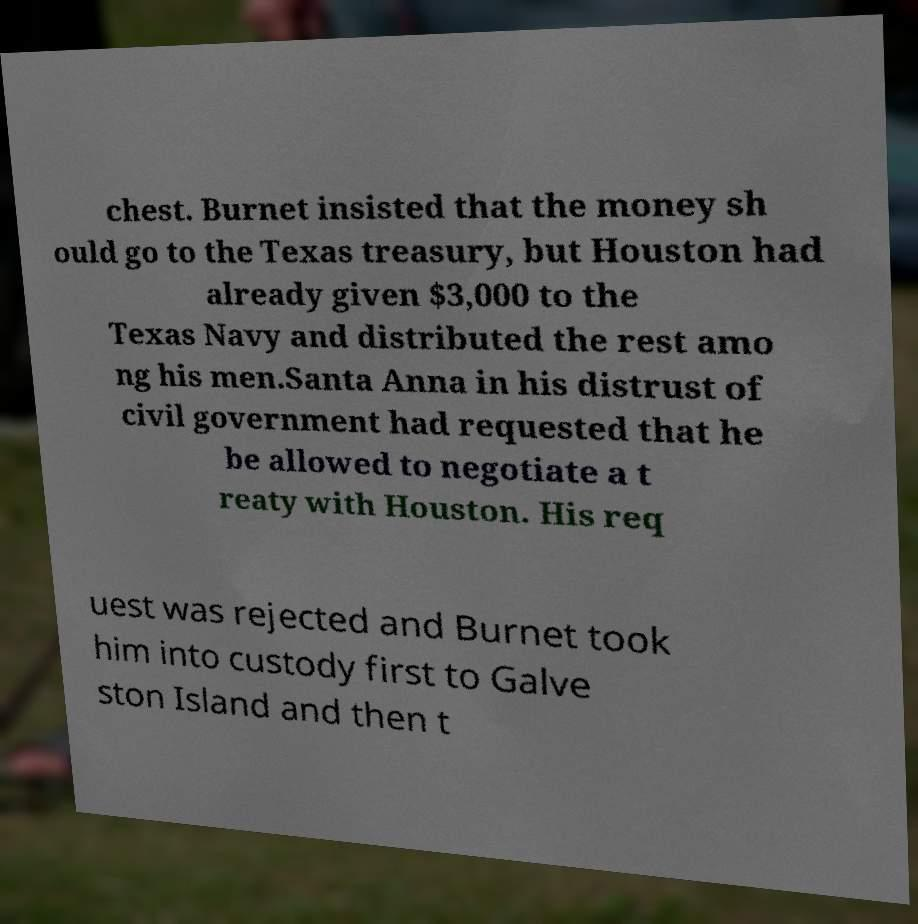There's text embedded in this image that I need extracted. Can you transcribe it verbatim? chest. Burnet insisted that the money sh ould go to the Texas treasury, but Houston had already given $3,000 to the Texas Navy and distributed the rest amo ng his men.Santa Anna in his distrust of civil government had requested that he be allowed to negotiate a t reaty with Houston. His req uest was rejected and Burnet took him into custody first to Galve ston Island and then t 